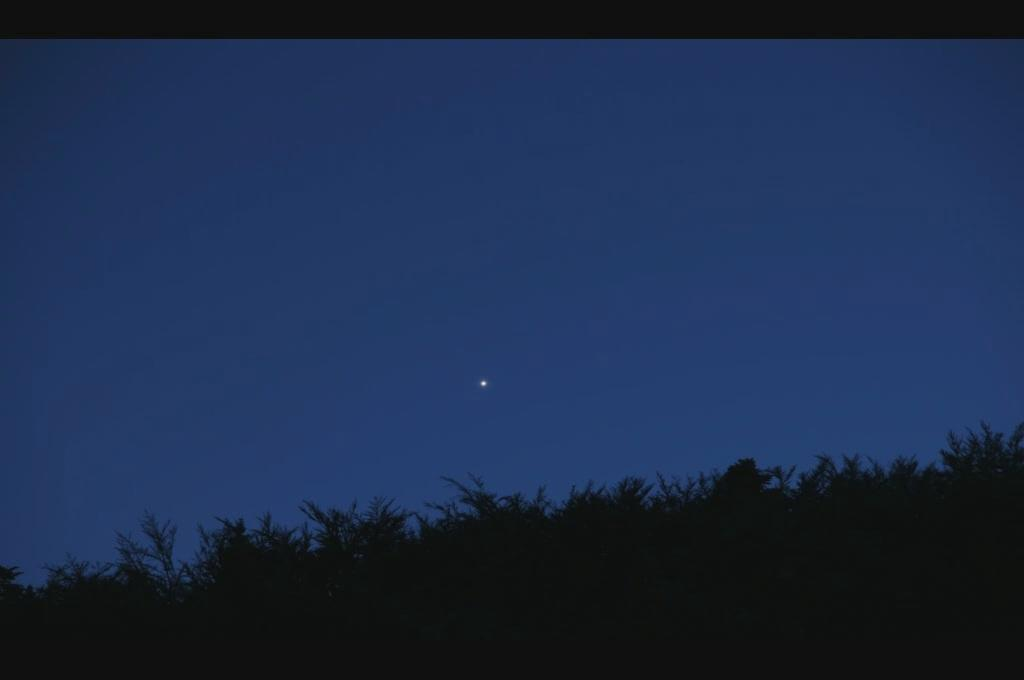What type of vegetation can be seen in the image? There are trees in the image. What part of the natural environment is visible in the background of the image? The sky is visible in the background of the image. Can the moon be seen in the sky in the background of the image? Yes, the moon is observable in the sky in the background of the image. How many eyes can be seen on the trees in the image? Trees do not have eyes, so this question cannot be answered definitively based on the information given. 